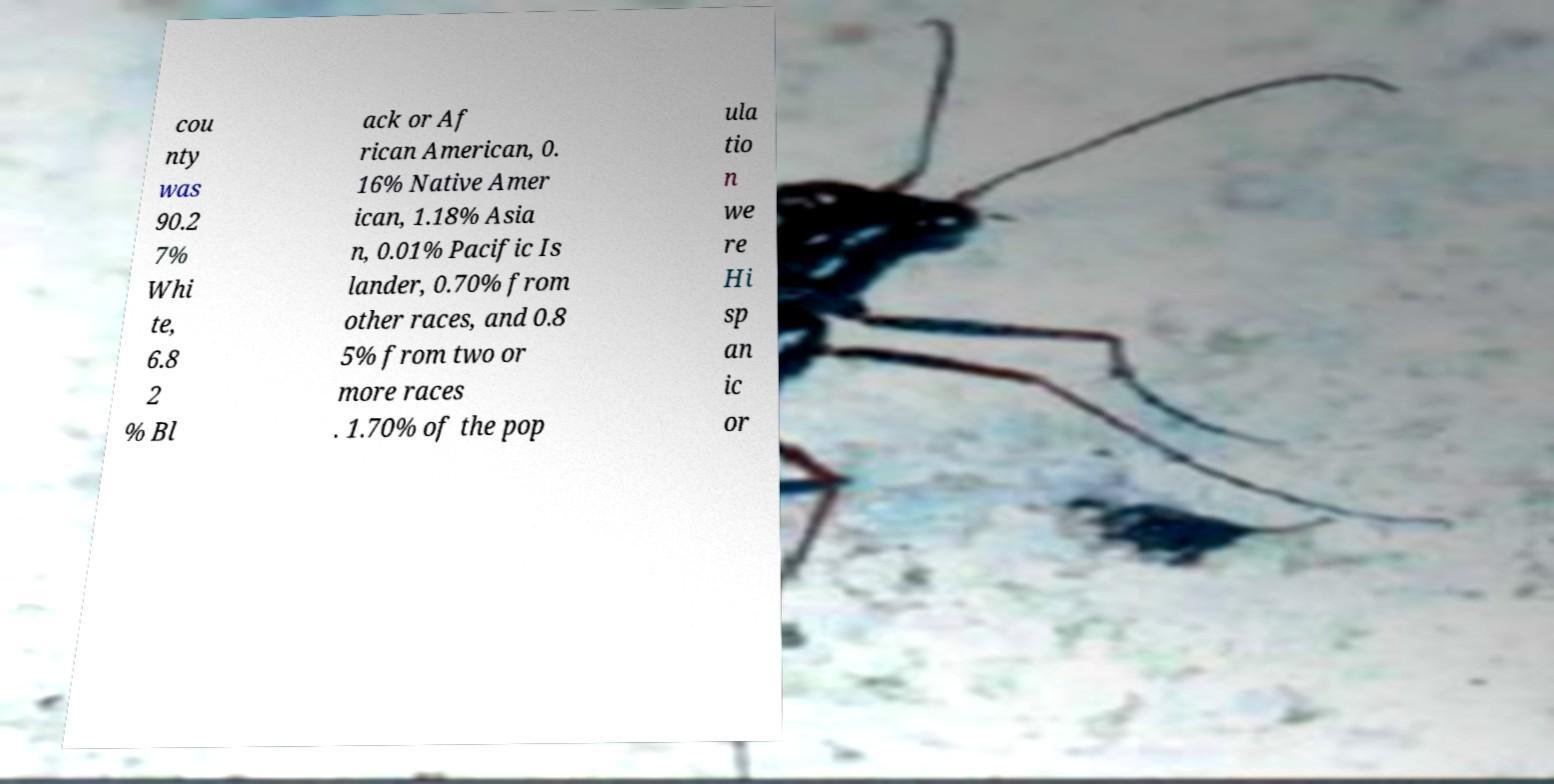There's text embedded in this image that I need extracted. Can you transcribe it verbatim? cou nty was 90.2 7% Whi te, 6.8 2 % Bl ack or Af rican American, 0. 16% Native Amer ican, 1.18% Asia n, 0.01% Pacific Is lander, 0.70% from other races, and 0.8 5% from two or more races . 1.70% of the pop ula tio n we re Hi sp an ic or 